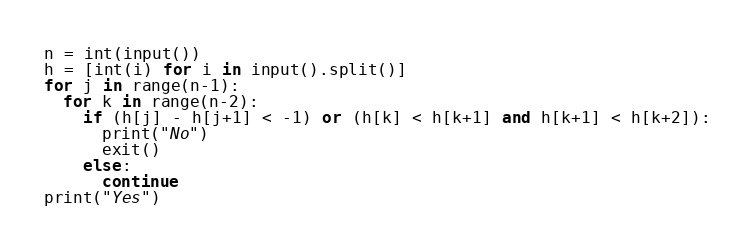Convert code to text. <code><loc_0><loc_0><loc_500><loc_500><_Python_>n = int(input())
h = [int(i) for i in input().split()]
for j in range(n-1):
  for k in range(n-2):
    if (h[j] - h[j+1] < -1) or (h[k] < h[k+1] and h[k+1] < h[k+2]):
      print("No")
      exit()
    else:
      continue
print("Yes")
</code> 